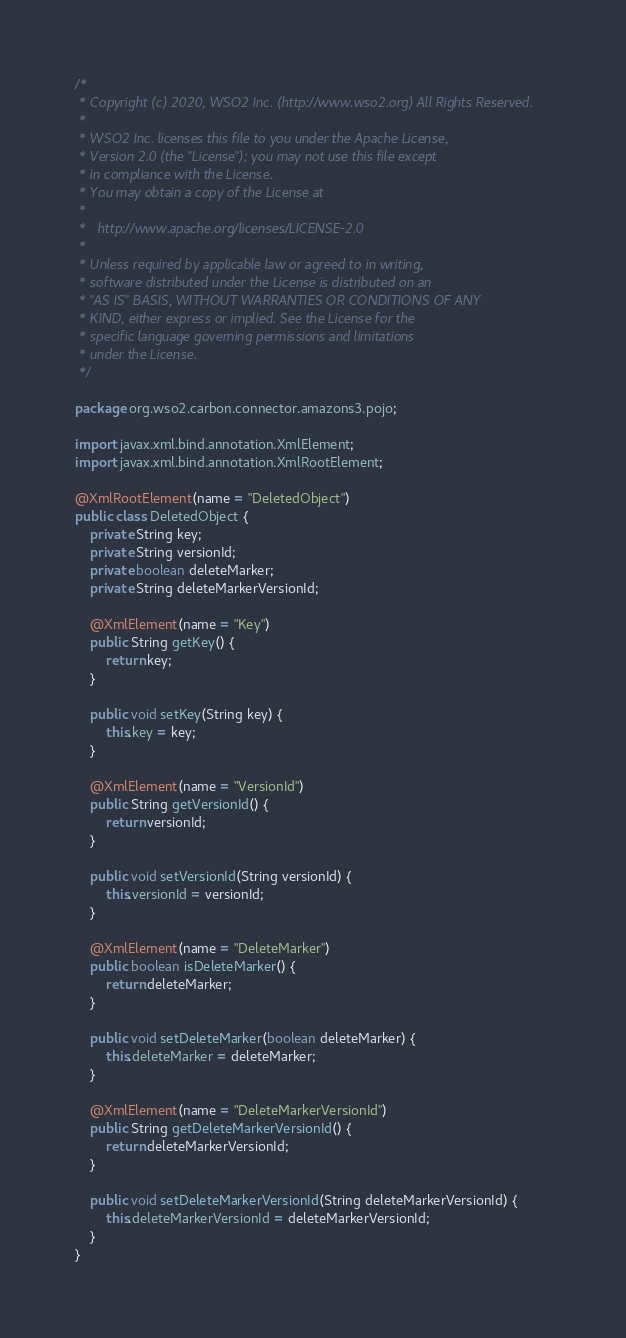<code> <loc_0><loc_0><loc_500><loc_500><_Java_>/*
 * Copyright (c) 2020, WSO2 Inc. (http://www.wso2.org) All Rights Reserved.
 *
 * WSO2 Inc. licenses this file to you under the Apache License,
 * Version 2.0 (the "License"); you may not use this file except
 * in compliance with the License.
 * You may obtain a copy of the License at
 *
 *   http://www.apache.org/licenses/LICENSE-2.0
 *
 * Unless required by applicable law or agreed to in writing,
 * software distributed under the License is distributed on an
 * "AS IS" BASIS, WITHOUT WARRANTIES OR CONDITIONS OF ANY
 * KIND, either express or implied. See the License for the
 * specific language governing permissions and limitations
 * under the License.
 */

package org.wso2.carbon.connector.amazons3.pojo;

import javax.xml.bind.annotation.XmlElement;
import javax.xml.bind.annotation.XmlRootElement;

@XmlRootElement(name = "DeletedObject")
public class DeletedObject {
    private String key;
    private String versionId;
    private boolean deleteMarker;
    private String deleteMarkerVersionId;

    @XmlElement(name = "Key")
    public String getKey() {
        return key;
    }

    public void setKey(String key) {
        this.key = key;
    }

    @XmlElement(name = "VersionId")
    public String getVersionId() {
        return versionId;
    }

    public void setVersionId(String versionId) {
        this.versionId = versionId;
    }

    @XmlElement(name = "DeleteMarker")
    public boolean isDeleteMarker() {
        return deleteMarker;
    }

    public void setDeleteMarker(boolean deleteMarker) {
        this.deleteMarker = deleteMarker;
    }

    @XmlElement(name = "DeleteMarkerVersionId")
    public String getDeleteMarkerVersionId() {
        return deleteMarkerVersionId;
    }

    public void setDeleteMarkerVersionId(String deleteMarkerVersionId) {
        this.deleteMarkerVersionId = deleteMarkerVersionId;
    }
}</code> 